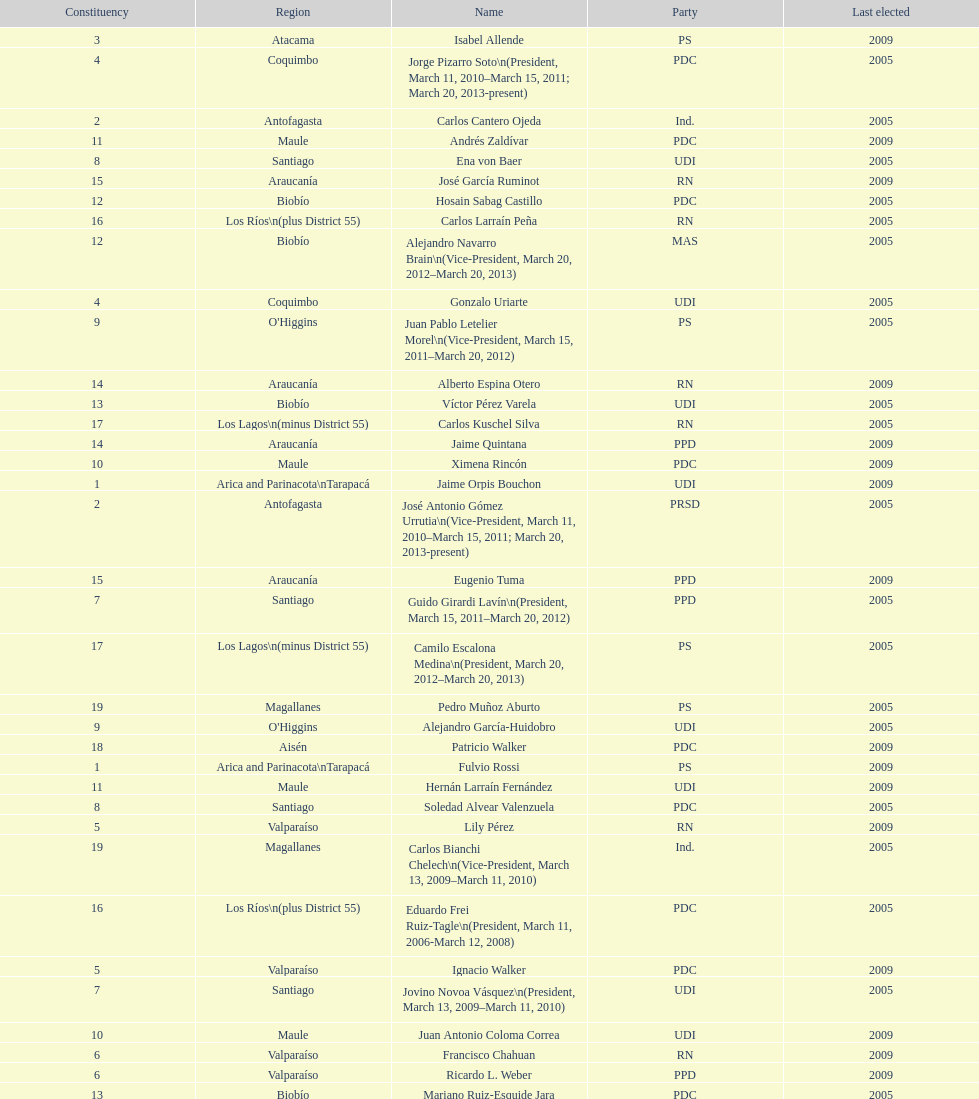What is the last region listed on the table? Magallanes. 